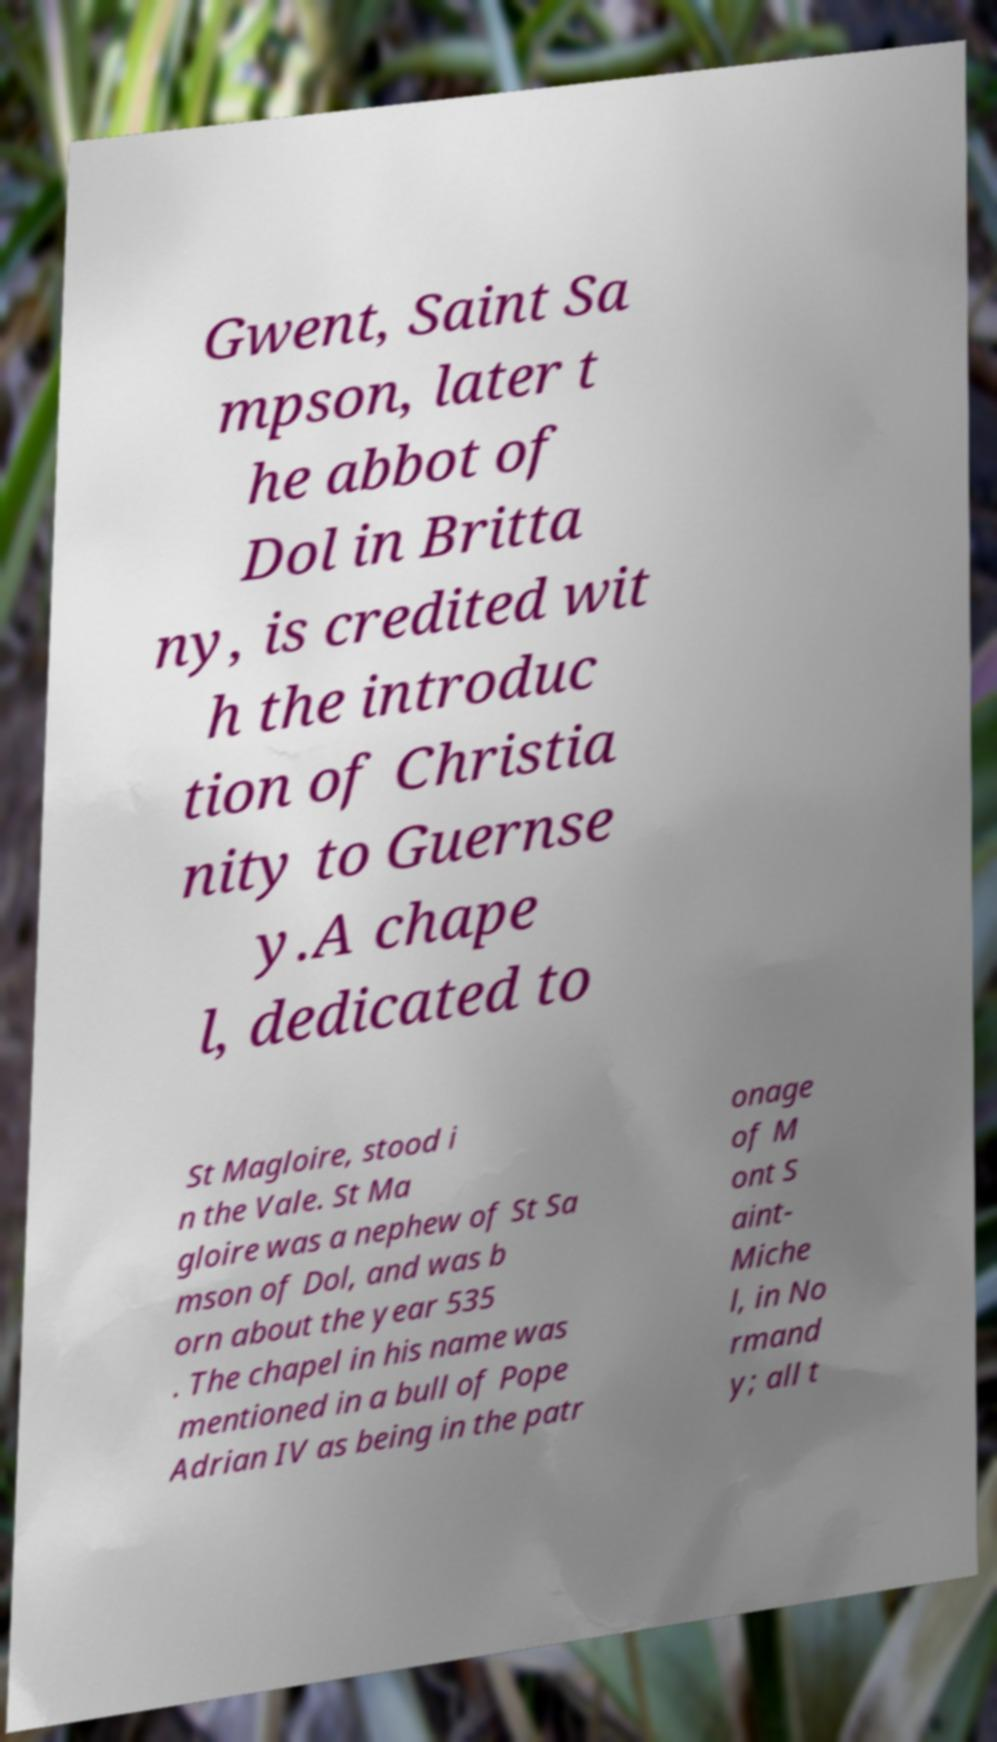Can you read and provide the text displayed in the image?This photo seems to have some interesting text. Can you extract and type it out for me? Gwent, Saint Sa mpson, later t he abbot of Dol in Britta ny, is credited wit h the introduc tion of Christia nity to Guernse y.A chape l, dedicated to St Magloire, stood i n the Vale. St Ma gloire was a nephew of St Sa mson of Dol, and was b orn about the year 535 . The chapel in his name was mentioned in a bull of Pope Adrian IV as being in the patr onage of M ont S aint- Miche l, in No rmand y; all t 